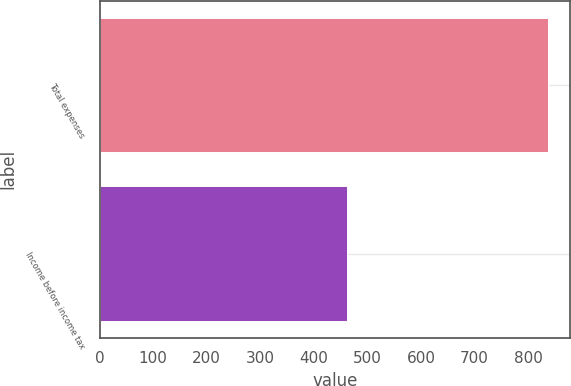Convert chart. <chart><loc_0><loc_0><loc_500><loc_500><bar_chart><fcel>Total expenses<fcel>Income before income tax<nl><fcel>836<fcel>461<nl></chart> 